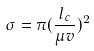Convert formula to latex. <formula><loc_0><loc_0><loc_500><loc_500>\sigma = \pi ( \frac { l _ { c } } { \mu v } ) ^ { 2 }</formula> 